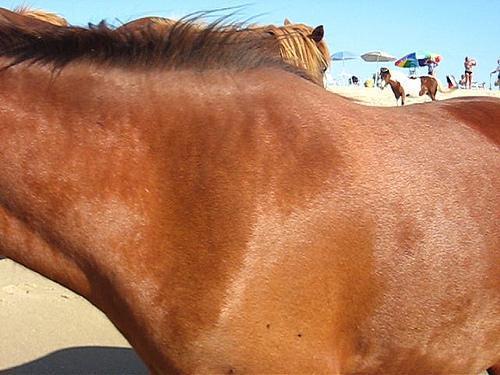How many horses are in this picture?
Give a very brief answer. 3. 